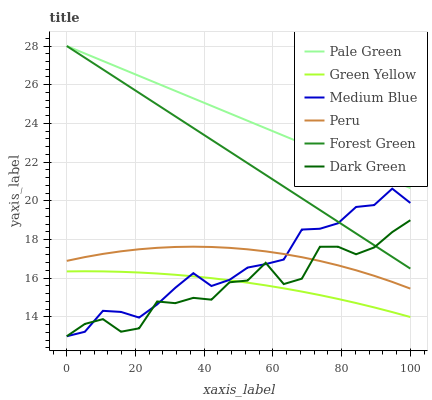Does Forest Green have the minimum area under the curve?
Answer yes or no. No. Does Forest Green have the maximum area under the curve?
Answer yes or no. No. Is Pale Green the smoothest?
Answer yes or no. No. Is Pale Green the roughest?
Answer yes or no. No. Does Forest Green have the lowest value?
Answer yes or no. No. Does Peru have the highest value?
Answer yes or no. No. Is Peru less than Forest Green?
Answer yes or no. Yes. Is Peru greater than Green Yellow?
Answer yes or no. Yes. Does Peru intersect Forest Green?
Answer yes or no. No. 